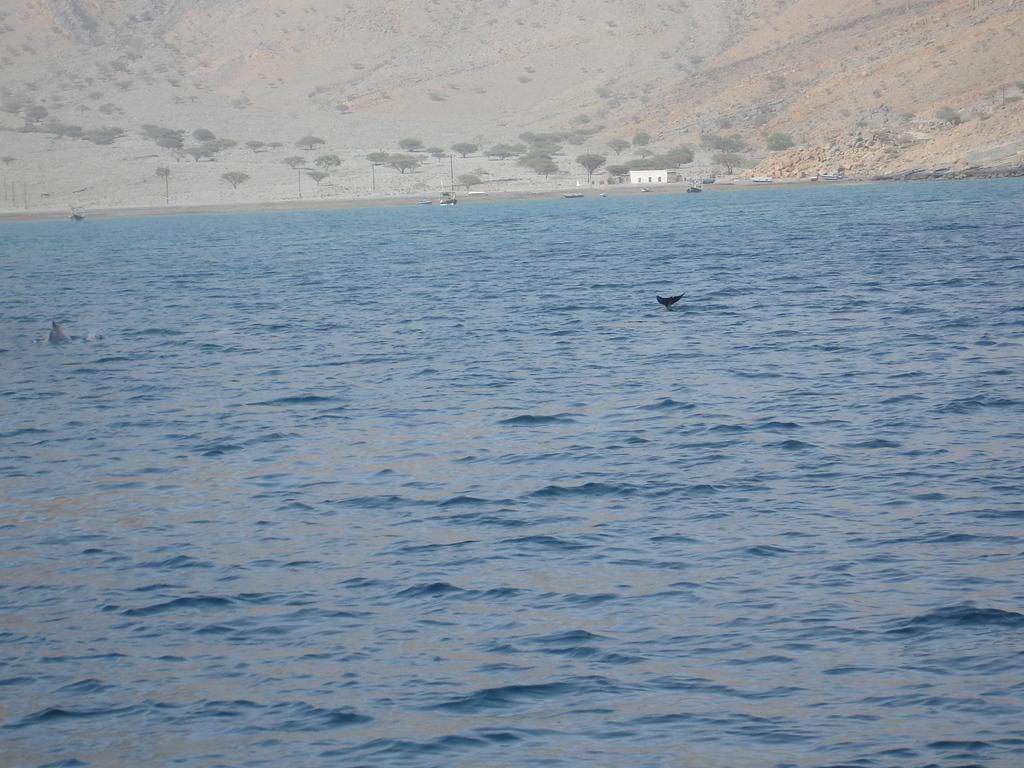Can you describe this image briefly? In this image there are boats sailing on the surface of the water. There is a house on the land having trees. Background there are hills. 